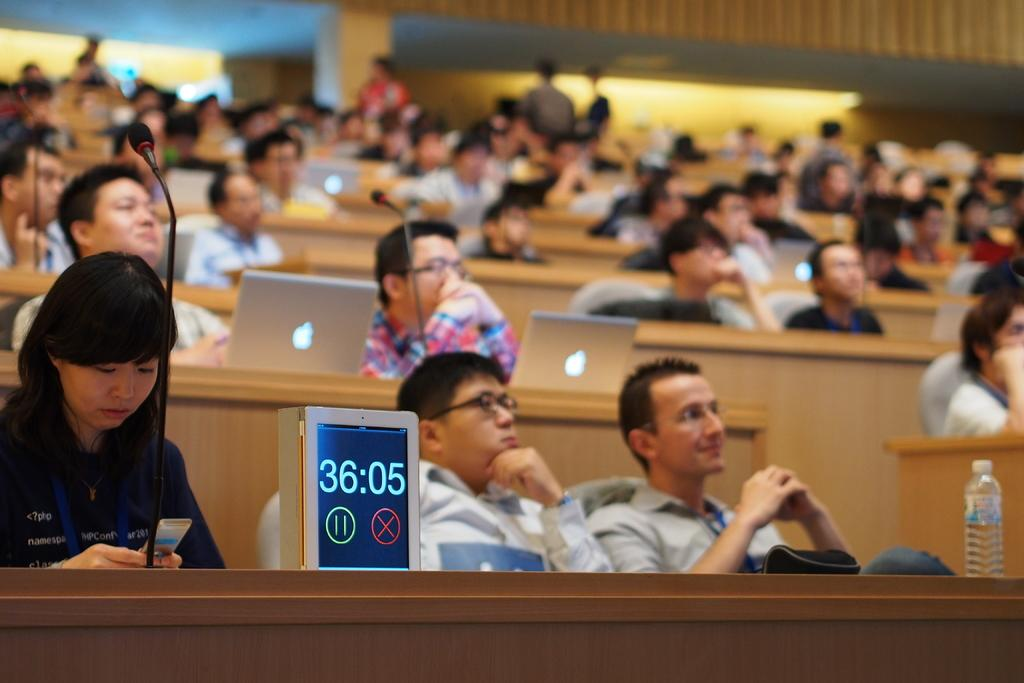How many people are in the image? There is a group of people in the image, but the exact number is not specified. What are the people in the image doing? Some people are sitting, while others are standing. What objects can be seen on the tables in the image? There are laptops, microphones, a digital clock, and a water bottle on the tables. What type of mint is being passed around in the image? There is no mint present in the image. What color is the suit worn by the person in the image? There is no person wearing a suit in the image. 